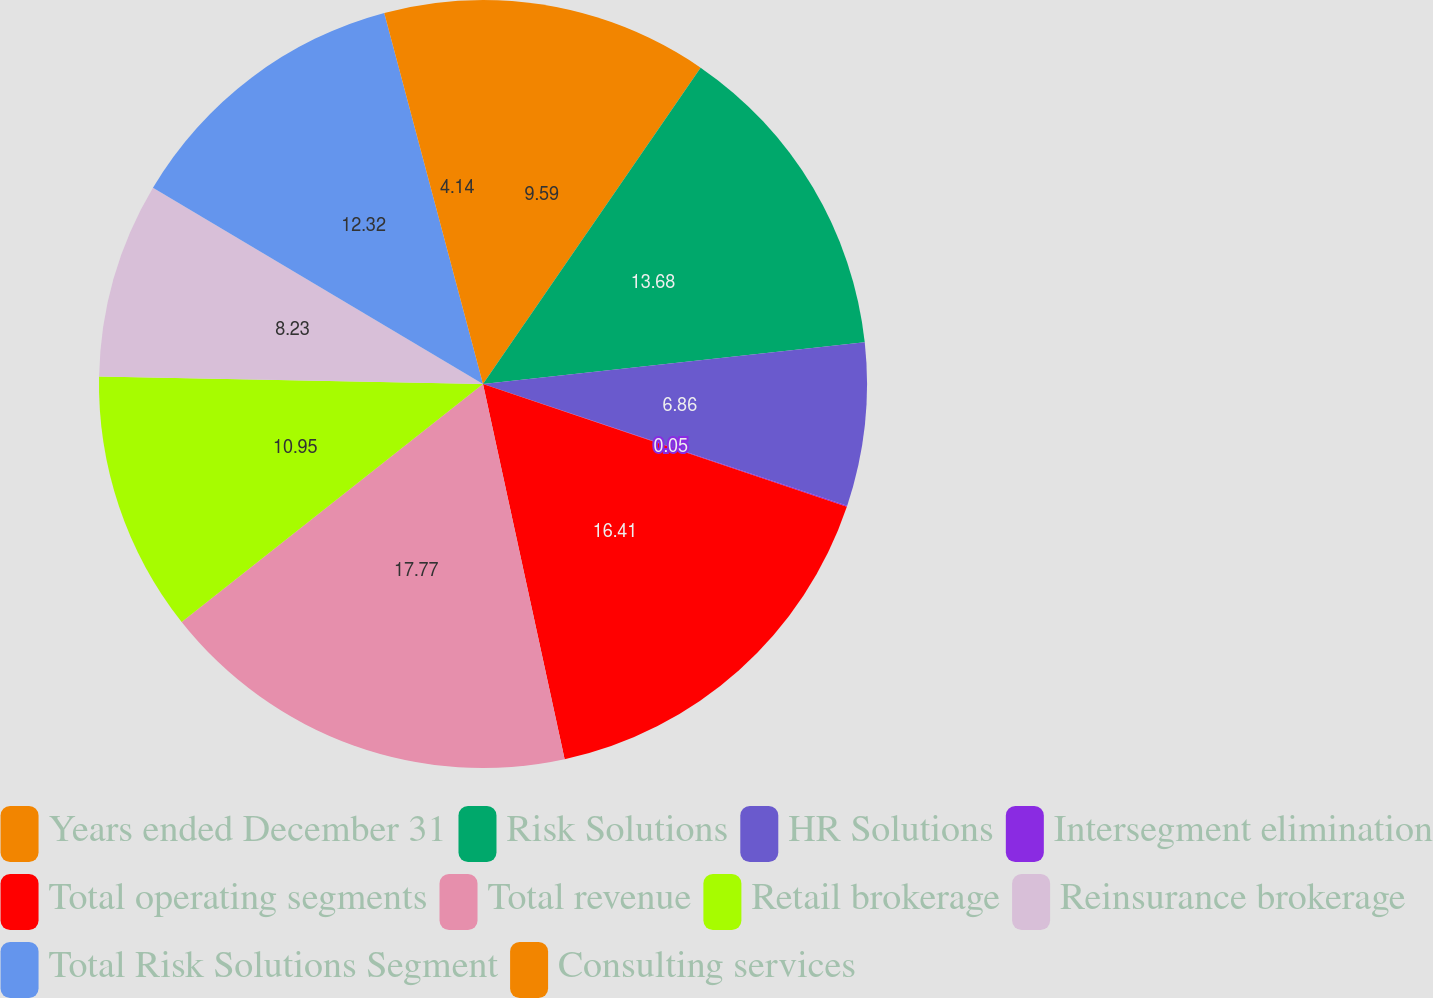Convert chart to OTSL. <chart><loc_0><loc_0><loc_500><loc_500><pie_chart><fcel>Years ended December 31<fcel>Risk Solutions<fcel>HR Solutions<fcel>Intersegment elimination<fcel>Total operating segments<fcel>Total revenue<fcel>Retail brokerage<fcel>Reinsurance brokerage<fcel>Total Risk Solutions Segment<fcel>Consulting services<nl><fcel>9.59%<fcel>13.68%<fcel>6.86%<fcel>0.05%<fcel>16.41%<fcel>17.77%<fcel>10.95%<fcel>8.23%<fcel>12.32%<fcel>4.14%<nl></chart> 